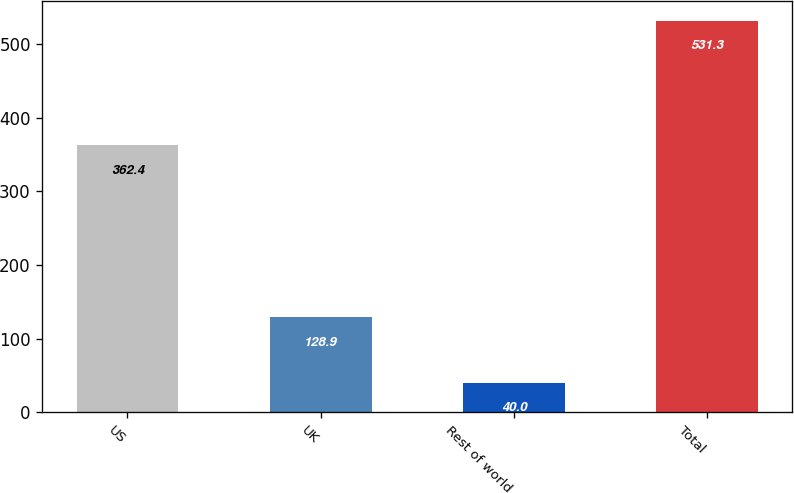Convert chart to OTSL. <chart><loc_0><loc_0><loc_500><loc_500><bar_chart><fcel>US<fcel>UK<fcel>Rest of world<fcel>Total<nl><fcel>362.4<fcel>128.9<fcel>40<fcel>531.3<nl></chart> 